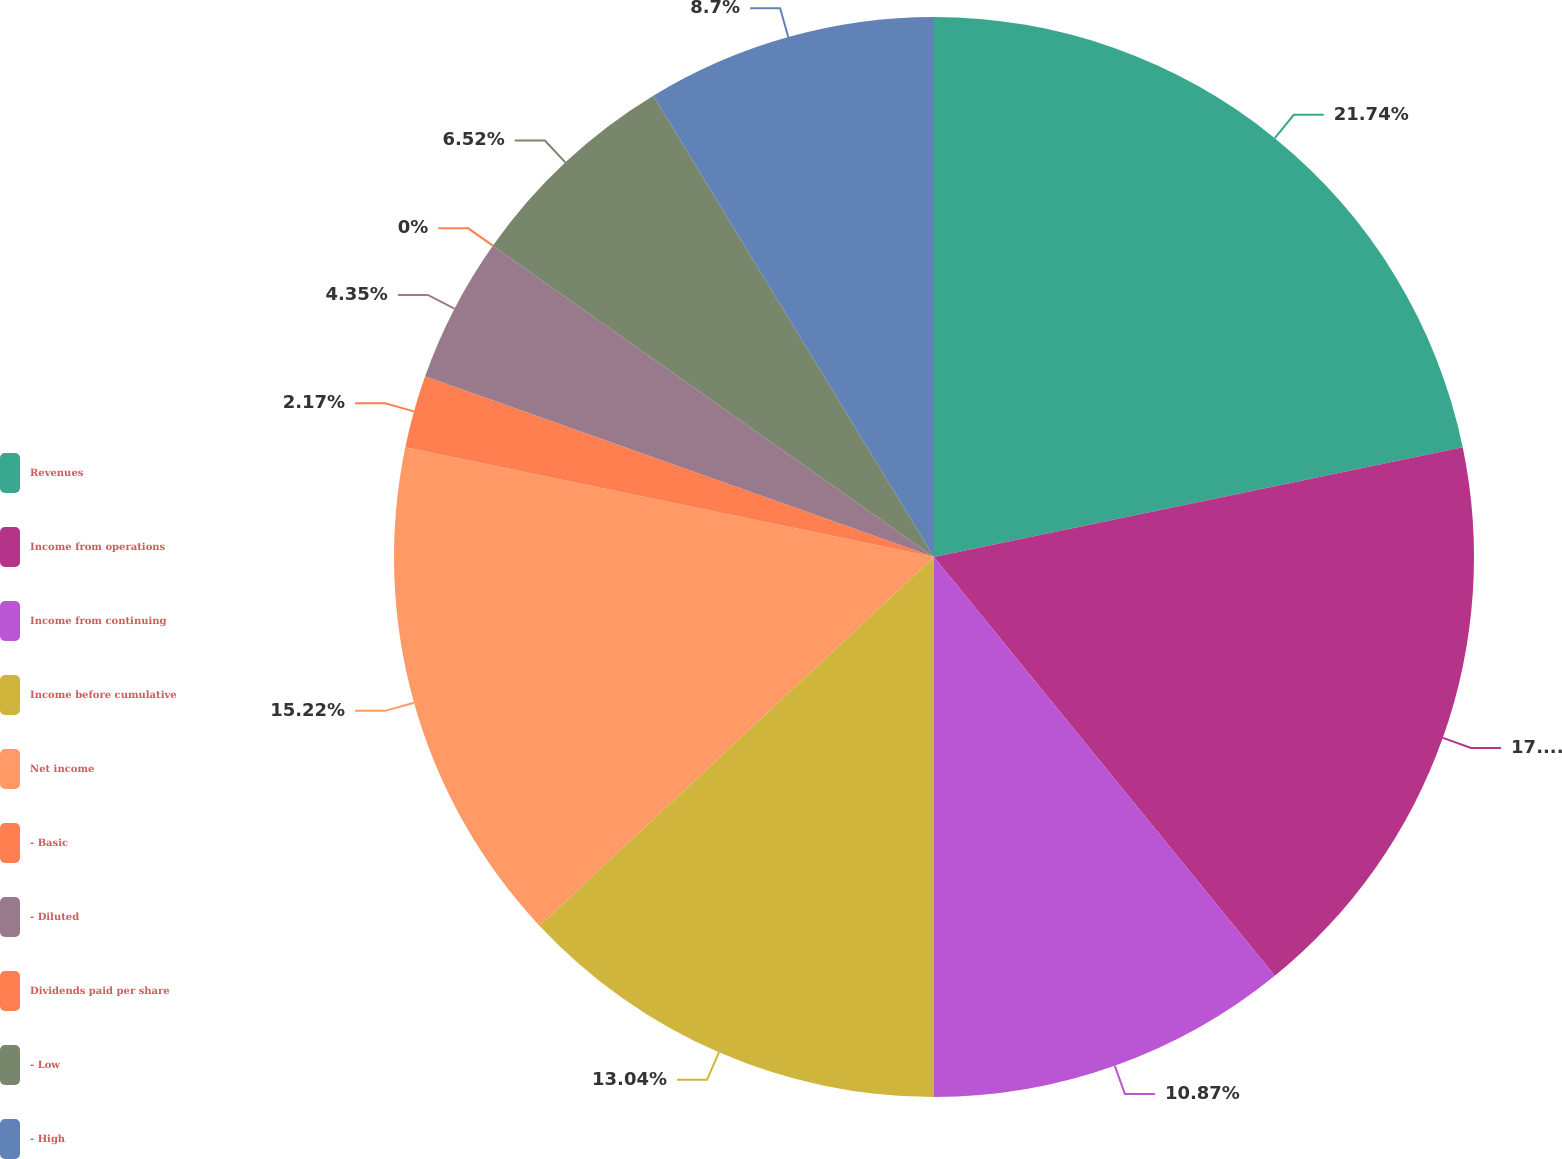<chart> <loc_0><loc_0><loc_500><loc_500><pie_chart><fcel>Revenues<fcel>Income from operations<fcel>Income from continuing<fcel>Income before cumulative<fcel>Net income<fcel>- Basic<fcel>- Diluted<fcel>Dividends paid per share<fcel>- Low<fcel>- High<nl><fcel>21.74%<fcel>17.39%<fcel>10.87%<fcel>13.04%<fcel>15.22%<fcel>2.17%<fcel>4.35%<fcel>0.0%<fcel>6.52%<fcel>8.7%<nl></chart> 